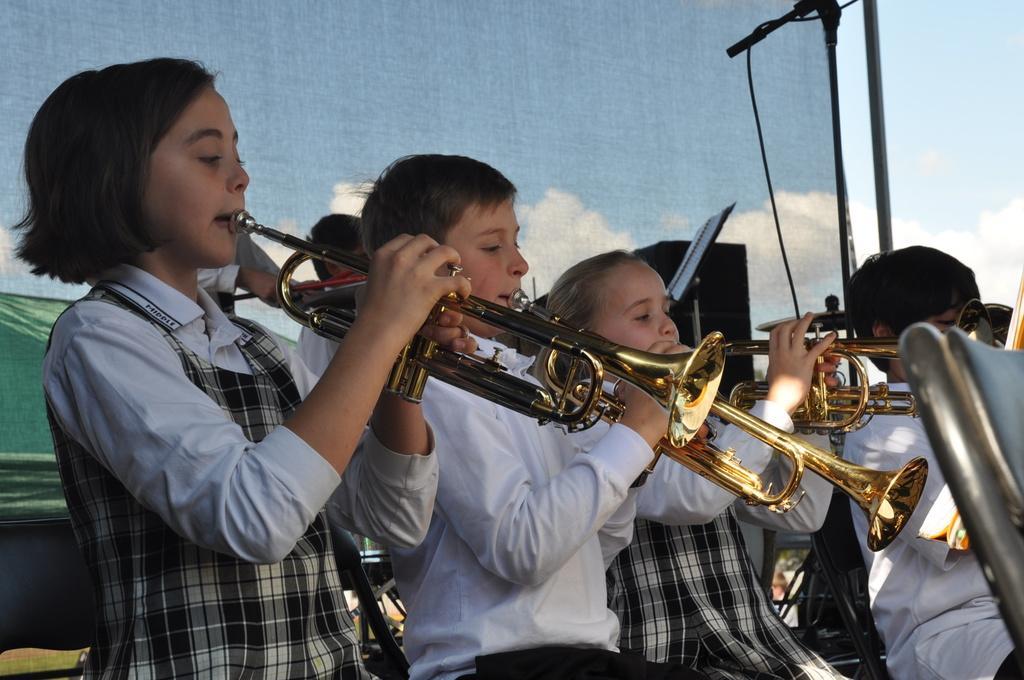How would you summarize this image in a sentence or two? In this image we can see kids playing trumpets. There is a mic placed on the stand. In the background there is a curtain and sky. We can see a speaker. 